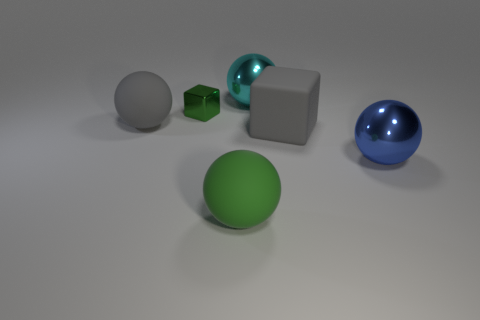Does the big thing that is behind the large gray sphere have the same material as the big green sphere?
Your answer should be compact. No. Do the large blue metallic object and the small green metal thing have the same shape?
Your answer should be very brief. No. What number of big matte things are to the left of the object in front of the blue shiny ball?
Make the answer very short. 1. There is a big gray object that is the same shape as the big cyan metal thing; what is its material?
Give a very brief answer. Rubber. There is a large rubber ball behind the blue sphere; does it have the same color as the small metallic block?
Make the answer very short. No. Is the material of the blue thing the same as the large gray thing right of the green sphere?
Offer a terse response. No. What shape is the gray object to the right of the large green object?
Offer a terse response. Cube. How many other objects are the same material as the big blue thing?
Provide a succinct answer. 2. What is the size of the gray matte block?
Your answer should be compact. Large. What number of other objects are there of the same color as the metallic block?
Offer a very short reply. 1. 